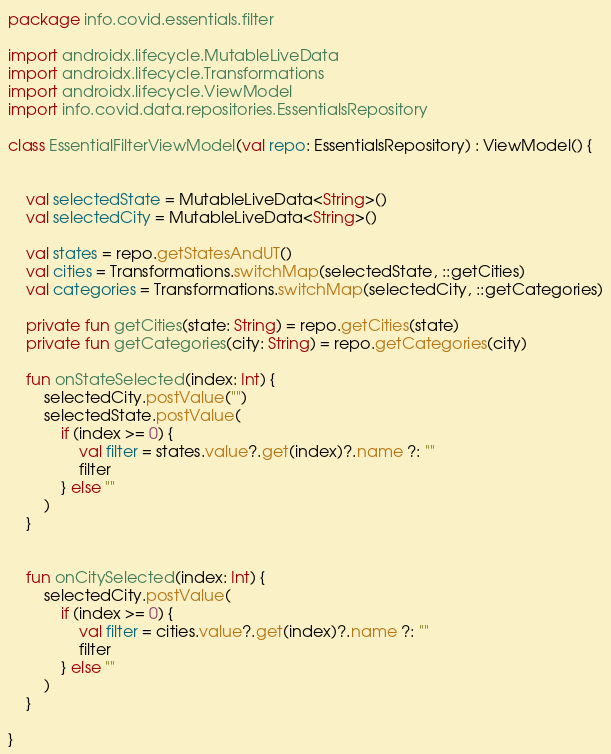<code> <loc_0><loc_0><loc_500><loc_500><_Kotlin_>package info.covid.essentials.filter

import androidx.lifecycle.MutableLiveData
import androidx.lifecycle.Transformations
import androidx.lifecycle.ViewModel
import info.covid.data.repositories.EssentialsRepository

class EssentialFilterViewModel(val repo: EssentialsRepository) : ViewModel() {


    val selectedState = MutableLiveData<String>()
    val selectedCity = MutableLiveData<String>()

    val states = repo.getStatesAndUT()
    val cities = Transformations.switchMap(selectedState, ::getCities)
    val categories = Transformations.switchMap(selectedCity, ::getCategories)

    private fun getCities(state: String) = repo.getCities(state)
    private fun getCategories(city: String) = repo.getCategories(city)

    fun onStateSelected(index: Int) {
        selectedCity.postValue("")
        selectedState.postValue(
            if (index >= 0) {
                val filter = states.value?.get(index)?.name ?: ""
                filter
            } else ""
        )
    }


    fun onCitySelected(index: Int) {
        selectedCity.postValue(
            if (index >= 0) {
                val filter = cities.value?.get(index)?.name ?: ""
                filter
            } else ""
        )
    }

}</code> 